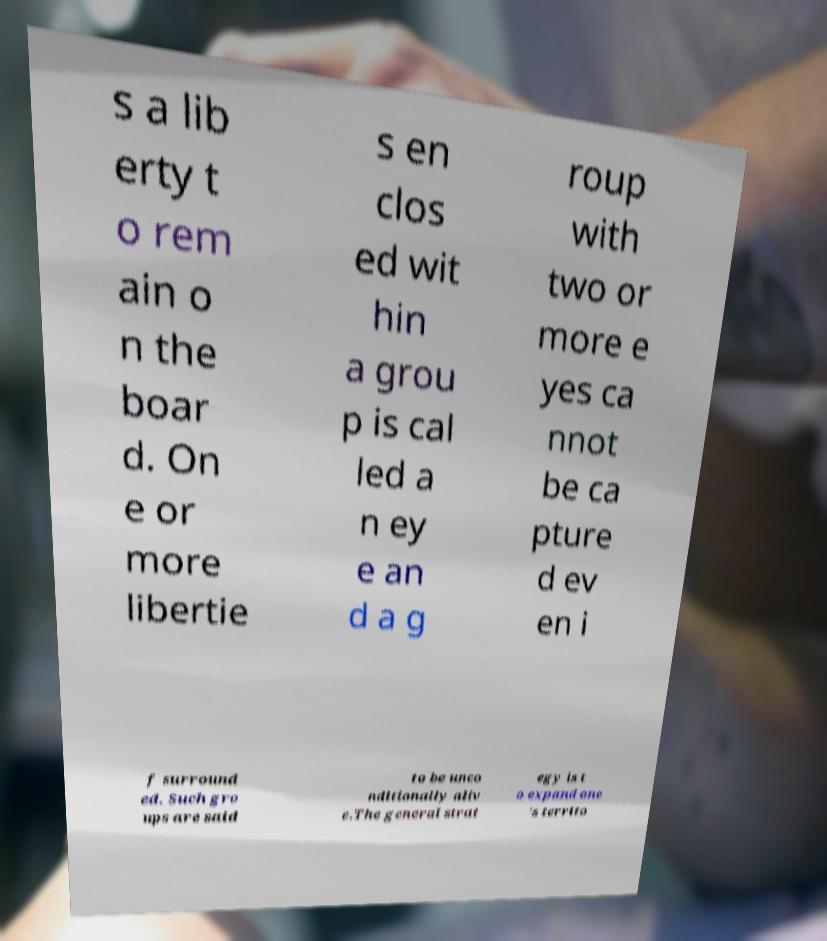There's text embedded in this image that I need extracted. Can you transcribe it verbatim? s a lib erty t o rem ain o n the boar d. On e or more libertie s en clos ed wit hin a grou p is cal led a n ey e an d a g roup with two or more e yes ca nnot be ca pture d ev en i f surround ed. Such gro ups are said to be unco nditionally aliv e.The general strat egy is t o expand one 's territo 